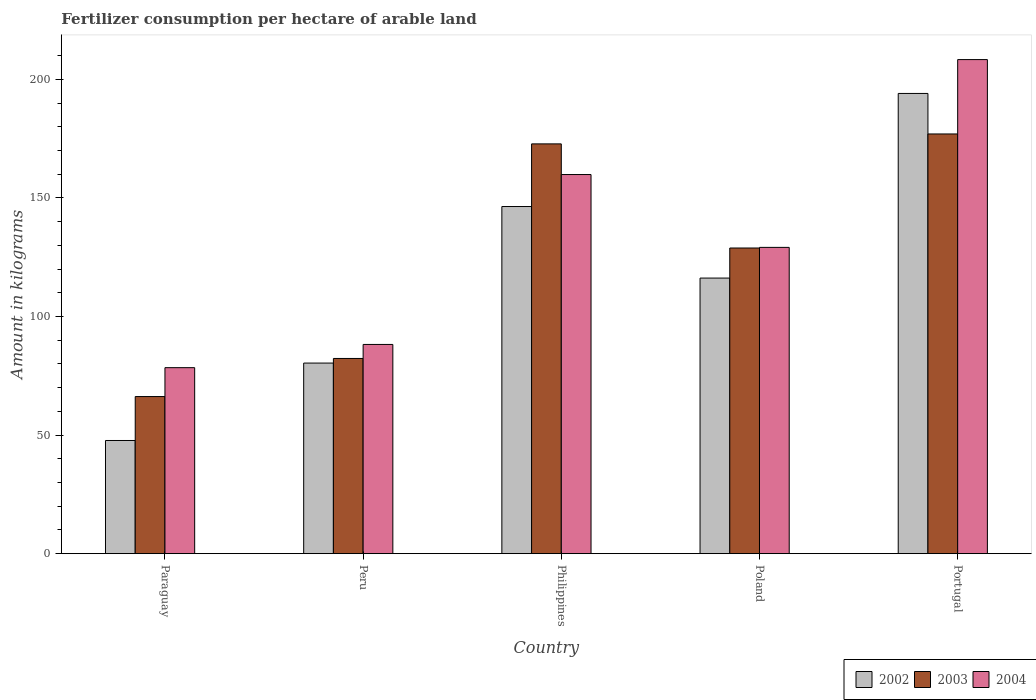How many groups of bars are there?
Give a very brief answer. 5. Are the number of bars on each tick of the X-axis equal?
Your answer should be compact. Yes. How many bars are there on the 1st tick from the left?
Keep it short and to the point. 3. In how many cases, is the number of bars for a given country not equal to the number of legend labels?
Offer a terse response. 0. What is the amount of fertilizer consumption in 2002 in Philippines?
Your answer should be compact. 146.36. Across all countries, what is the maximum amount of fertilizer consumption in 2002?
Your answer should be very brief. 194.04. Across all countries, what is the minimum amount of fertilizer consumption in 2004?
Ensure brevity in your answer.  78.42. In which country was the amount of fertilizer consumption in 2004 minimum?
Make the answer very short. Paraguay. What is the total amount of fertilizer consumption in 2002 in the graph?
Your response must be concise. 584.66. What is the difference between the amount of fertilizer consumption in 2002 in Paraguay and that in Portugal?
Keep it short and to the point. -146.32. What is the difference between the amount of fertilizer consumption in 2004 in Philippines and the amount of fertilizer consumption in 2002 in Paraguay?
Your answer should be compact. 112.13. What is the average amount of fertilizer consumption in 2002 per country?
Offer a very short reply. 116.93. What is the difference between the amount of fertilizer consumption of/in 2004 and amount of fertilizer consumption of/in 2003 in Paraguay?
Give a very brief answer. 12.18. In how many countries, is the amount of fertilizer consumption in 2003 greater than 110 kg?
Give a very brief answer. 3. What is the ratio of the amount of fertilizer consumption in 2004 in Poland to that in Portugal?
Make the answer very short. 0.62. Is the amount of fertilizer consumption in 2004 in Peru less than that in Philippines?
Ensure brevity in your answer.  Yes. What is the difference between the highest and the second highest amount of fertilizer consumption in 2002?
Offer a terse response. 77.84. What is the difference between the highest and the lowest amount of fertilizer consumption in 2002?
Provide a short and direct response. 146.32. In how many countries, is the amount of fertilizer consumption in 2003 greater than the average amount of fertilizer consumption in 2003 taken over all countries?
Ensure brevity in your answer.  3. How many bars are there?
Make the answer very short. 15. What is the difference between two consecutive major ticks on the Y-axis?
Provide a succinct answer. 50. Are the values on the major ticks of Y-axis written in scientific E-notation?
Keep it short and to the point. No. Does the graph contain any zero values?
Your response must be concise. No. Does the graph contain grids?
Your answer should be compact. No. How many legend labels are there?
Your answer should be very brief. 3. How are the legend labels stacked?
Ensure brevity in your answer.  Horizontal. What is the title of the graph?
Offer a very short reply. Fertilizer consumption per hectare of arable land. What is the label or title of the X-axis?
Your answer should be compact. Country. What is the label or title of the Y-axis?
Offer a terse response. Amount in kilograms. What is the Amount in kilograms in 2002 in Paraguay?
Offer a terse response. 47.72. What is the Amount in kilograms in 2003 in Paraguay?
Provide a short and direct response. 66.24. What is the Amount in kilograms of 2004 in Paraguay?
Your answer should be compact. 78.42. What is the Amount in kilograms of 2002 in Peru?
Provide a succinct answer. 80.35. What is the Amount in kilograms of 2003 in Peru?
Provide a short and direct response. 82.3. What is the Amount in kilograms in 2004 in Peru?
Offer a terse response. 88.21. What is the Amount in kilograms in 2002 in Philippines?
Offer a terse response. 146.36. What is the Amount in kilograms of 2003 in Philippines?
Ensure brevity in your answer.  172.77. What is the Amount in kilograms of 2004 in Philippines?
Offer a terse response. 159.85. What is the Amount in kilograms of 2002 in Poland?
Your answer should be very brief. 116.2. What is the Amount in kilograms in 2003 in Poland?
Your answer should be compact. 128.87. What is the Amount in kilograms of 2004 in Poland?
Provide a short and direct response. 129.14. What is the Amount in kilograms of 2002 in Portugal?
Your answer should be compact. 194.04. What is the Amount in kilograms of 2003 in Portugal?
Keep it short and to the point. 176.96. What is the Amount in kilograms of 2004 in Portugal?
Provide a short and direct response. 208.31. Across all countries, what is the maximum Amount in kilograms of 2002?
Give a very brief answer. 194.04. Across all countries, what is the maximum Amount in kilograms in 2003?
Ensure brevity in your answer.  176.96. Across all countries, what is the maximum Amount in kilograms of 2004?
Give a very brief answer. 208.31. Across all countries, what is the minimum Amount in kilograms of 2002?
Offer a very short reply. 47.72. Across all countries, what is the minimum Amount in kilograms in 2003?
Make the answer very short. 66.24. Across all countries, what is the minimum Amount in kilograms of 2004?
Give a very brief answer. 78.42. What is the total Amount in kilograms of 2002 in the graph?
Make the answer very short. 584.66. What is the total Amount in kilograms in 2003 in the graph?
Provide a succinct answer. 627.13. What is the total Amount in kilograms of 2004 in the graph?
Provide a short and direct response. 663.93. What is the difference between the Amount in kilograms in 2002 in Paraguay and that in Peru?
Keep it short and to the point. -32.64. What is the difference between the Amount in kilograms in 2003 in Paraguay and that in Peru?
Make the answer very short. -16.06. What is the difference between the Amount in kilograms in 2004 in Paraguay and that in Peru?
Your response must be concise. -9.79. What is the difference between the Amount in kilograms in 2002 in Paraguay and that in Philippines?
Provide a short and direct response. -98.65. What is the difference between the Amount in kilograms in 2003 in Paraguay and that in Philippines?
Offer a very short reply. -106.53. What is the difference between the Amount in kilograms in 2004 in Paraguay and that in Philippines?
Your answer should be compact. -81.42. What is the difference between the Amount in kilograms of 2002 in Paraguay and that in Poland?
Offer a terse response. -68.48. What is the difference between the Amount in kilograms of 2003 in Paraguay and that in Poland?
Ensure brevity in your answer.  -62.63. What is the difference between the Amount in kilograms of 2004 in Paraguay and that in Poland?
Make the answer very short. -50.71. What is the difference between the Amount in kilograms in 2002 in Paraguay and that in Portugal?
Make the answer very short. -146.32. What is the difference between the Amount in kilograms of 2003 in Paraguay and that in Portugal?
Your answer should be compact. -110.72. What is the difference between the Amount in kilograms of 2004 in Paraguay and that in Portugal?
Provide a short and direct response. -129.89. What is the difference between the Amount in kilograms in 2002 in Peru and that in Philippines?
Offer a terse response. -66.01. What is the difference between the Amount in kilograms in 2003 in Peru and that in Philippines?
Your response must be concise. -90.47. What is the difference between the Amount in kilograms of 2004 in Peru and that in Philippines?
Your response must be concise. -71.63. What is the difference between the Amount in kilograms in 2002 in Peru and that in Poland?
Your response must be concise. -35.84. What is the difference between the Amount in kilograms in 2003 in Peru and that in Poland?
Your answer should be compact. -46.57. What is the difference between the Amount in kilograms in 2004 in Peru and that in Poland?
Give a very brief answer. -40.92. What is the difference between the Amount in kilograms in 2002 in Peru and that in Portugal?
Provide a succinct answer. -113.68. What is the difference between the Amount in kilograms in 2003 in Peru and that in Portugal?
Make the answer very short. -94.66. What is the difference between the Amount in kilograms in 2004 in Peru and that in Portugal?
Offer a terse response. -120.1. What is the difference between the Amount in kilograms of 2002 in Philippines and that in Poland?
Ensure brevity in your answer.  30.17. What is the difference between the Amount in kilograms in 2003 in Philippines and that in Poland?
Give a very brief answer. 43.9. What is the difference between the Amount in kilograms of 2004 in Philippines and that in Poland?
Make the answer very short. 30.71. What is the difference between the Amount in kilograms in 2002 in Philippines and that in Portugal?
Keep it short and to the point. -47.68. What is the difference between the Amount in kilograms of 2003 in Philippines and that in Portugal?
Offer a very short reply. -4.19. What is the difference between the Amount in kilograms in 2004 in Philippines and that in Portugal?
Ensure brevity in your answer.  -48.47. What is the difference between the Amount in kilograms in 2002 in Poland and that in Portugal?
Your answer should be compact. -77.84. What is the difference between the Amount in kilograms of 2003 in Poland and that in Portugal?
Keep it short and to the point. -48.09. What is the difference between the Amount in kilograms in 2004 in Poland and that in Portugal?
Make the answer very short. -79.18. What is the difference between the Amount in kilograms of 2002 in Paraguay and the Amount in kilograms of 2003 in Peru?
Offer a terse response. -34.58. What is the difference between the Amount in kilograms in 2002 in Paraguay and the Amount in kilograms in 2004 in Peru?
Keep it short and to the point. -40.5. What is the difference between the Amount in kilograms in 2003 in Paraguay and the Amount in kilograms in 2004 in Peru?
Provide a succinct answer. -21.97. What is the difference between the Amount in kilograms of 2002 in Paraguay and the Amount in kilograms of 2003 in Philippines?
Ensure brevity in your answer.  -125.05. What is the difference between the Amount in kilograms of 2002 in Paraguay and the Amount in kilograms of 2004 in Philippines?
Provide a short and direct response. -112.13. What is the difference between the Amount in kilograms of 2003 in Paraguay and the Amount in kilograms of 2004 in Philippines?
Ensure brevity in your answer.  -93.61. What is the difference between the Amount in kilograms in 2002 in Paraguay and the Amount in kilograms in 2003 in Poland?
Your answer should be very brief. -81.16. What is the difference between the Amount in kilograms in 2002 in Paraguay and the Amount in kilograms in 2004 in Poland?
Offer a very short reply. -81.42. What is the difference between the Amount in kilograms in 2003 in Paraguay and the Amount in kilograms in 2004 in Poland?
Your answer should be compact. -62.9. What is the difference between the Amount in kilograms in 2002 in Paraguay and the Amount in kilograms in 2003 in Portugal?
Provide a succinct answer. -129.24. What is the difference between the Amount in kilograms of 2002 in Paraguay and the Amount in kilograms of 2004 in Portugal?
Offer a terse response. -160.6. What is the difference between the Amount in kilograms in 2003 in Paraguay and the Amount in kilograms in 2004 in Portugal?
Provide a succinct answer. -142.08. What is the difference between the Amount in kilograms of 2002 in Peru and the Amount in kilograms of 2003 in Philippines?
Give a very brief answer. -92.41. What is the difference between the Amount in kilograms of 2002 in Peru and the Amount in kilograms of 2004 in Philippines?
Your answer should be compact. -79.49. What is the difference between the Amount in kilograms in 2003 in Peru and the Amount in kilograms in 2004 in Philippines?
Offer a terse response. -77.55. What is the difference between the Amount in kilograms of 2002 in Peru and the Amount in kilograms of 2003 in Poland?
Your response must be concise. -48.52. What is the difference between the Amount in kilograms of 2002 in Peru and the Amount in kilograms of 2004 in Poland?
Provide a short and direct response. -48.78. What is the difference between the Amount in kilograms of 2003 in Peru and the Amount in kilograms of 2004 in Poland?
Your answer should be compact. -46.84. What is the difference between the Amount in kilograms of 2002 in Peru and the Amount in kilograms of 2003 in Portugal?
Your answer should be compact. -96.6. What is the difference between the Amount in kilograms in 2002 in Peru and the Amount in kilograms in 2004 in Portugal?
Your answer should be compact. -127.96. What is the difference between the Amount in kilograms of 2003 in Peru and the Amount in kilograms of 2004 in Portugal?
Give a very brief answer. -126.02. What is the difference between the Amount in kilograms of 2002 in Philippines and the Amount in kilograms of 2003 in Poland?
Your answer should be very brief. 17.49. What is the difference between the Amount in kilograms of 2002 in Philippines and the Amount in kilograms of 2004 in Poland?
Offer a very short reply. 17.23. What is the difference between the Amount in kilograms of 2003 in Philippines and the Amount in kilograms of 2004 in Poland?
Offer a terse response. 43.63. What is the difference between the Amount in kilograms in 2002 in Philippines and the Amount in kilograms in 2003 in Portugal?
Ensure brevity in your answer.  -30.6. What is the difference between the Amount in kilograms of 2002 in Philippines and the Amount in kilograms of 2004 in Portugal?
Offer a very short reply. -61.95. What is the difference between the Amount in kilograms in 2003 in Philippines and the Amount in kilograms in 2004 in Portugal?
Your response must be concise. -35.55. What is the difference between the Amount in kilograms in 2002 in Poland and the Amount in kilograms in 2003 in Portugal?
Keep it short and to the point. -60.76. What is the difference between the Amount in kilograms in 2002 in Poland and the Amount in kilograms in 2004 in Portugal?
Make the answer very short. -92.12. What is the difference between the Amount in kilograms of 2003 in Poland and the Amount in kilograms of 2004 in Portugal?
Your response must be concise. -79.44. What is the average Amount in kilograms in 2002 per country?
Give a very brief answer. 116.93. What is the average Amount in kilograms in 2003 per country?
Your response must be concise. 125.43. What is the average Amount in kilograms of 2004 per country?
Your response must be concise. 132.79. What is the difference between the Amount in kilograms in 2002 and Amount in kilograms in 2003 in Paraguay?
Provide a short and direct response. -18.52. What is the difference between the Amount in kilograms in 2002 and Amount in kilograms in 2004 in Paraguay?
Offer a very short reply. -30.71. What is the difference between the Amount in kilograms in 2003 and Amount in kilograms in 2004 in Paraguay?
Provide a succinct answer. -12.18. What is the difference between the Amount in kilograms of 2002 and Amount in kilograms of 2003 in Peru?
Provide a short and direct response. -1.94. What is the difference between the Amount in kilograms of 2002 and Amount in kilograms of 2004 in Peru?
Provide a short and direct response. -7.86. What is the difference between the Amount in kilograms in 2003 and Amount in kilograms in 2004 in Peru?
Offer a very short reply. -5.91. What is the difference between the Amount in kilograms in 2002 and Amount in kilograms in 2003 in Philippines?
Offer a terse response. -26.41. What is the difference between the Amount in kilograms in 2002 and Amount in kilograms in 2004 in Philippines?
Provide a succinct answer. -13.48. What is the difference between the Amount in kilograms of 2003 and Amount in kilograms of 2004 in Philippines?
Your answer should be very brief. 12.92. What is the difference between the Amount in kilograms of 2002 and Amount in kilograms of 2003 in Poland?
Give a very brief answer. -12.68. What is the difference between the Amount in kilograms of 2002 and Amount in kilograms of 2004 in Poland?
Give a very brief answer. -12.94. What is the difference between the Amount in kilograms of 2003 and Amount in kilograms of 2004 in Poland?
Your response must be concise. -0.26. What is the difference between the Amount in kilograms in 2002 and Amount in kilograms in 2003 in Portugal?
Provide a succinct answer. 17.08. What is the difference between the Amount in kilograms of 2002 and Amount in kilograms of 2004 in Portugal?
Your answer should be compact. -14.28. What is the difference between the Amount in kilograms of 2003 and Amount in kilograms of 2004 in Portugal?
Keep it short and to the point. -31.36. What is the ratio of the Amount in kilograms in 2002 in Paraguay to that in Peru?
Provide a short and direct response. 0.59. What is the ratio of the Amount in kilograms in 2003 in Paraguay to that in Peru?
Ensure brevity in your answer.  0.8. What is the ratio of the Amount in kilograms of 2004 in Paraguay to that in Peru?
Keep it short and to the point. 0.89. What is the ratio of the Amount in kilograms in 2002 in Paraguay to that in Philippines?
Keep it short and to the point. 0.33. What is the ratio of the Amount in kilograms in 2003 in Paraguay to that in Philippines?
Provide a short and direct response. 0.38. What is the ratio of the Amount in kilograms of 2004 in Paraguay to that in Philippines?
Make the answer very short. 0.49. What is the ratio of the Amount in kilograms of 2002 in Paraguay to that in Poland?
Your response must be concise. 0.41. What is the ratio of the Amount in kilograms in 2003 in Paraguay to that in Poland?
Offer a very short reply. 0.51. What is the ratio of the Amount in kilograms in 2004 in Paraguay to that in Poland?
Your response must be concise. 0.61. What is the ratio of the Amount in kilograms of 2002 in Paraguay to that in Portugal?
Give a very brief answer. 0.25. What is the ratio of the Amount in kilograms of 2003 in Paraguay to that in Portugal?
Provide a short and direct response. 0.37. What is the ratio of the Amount in kilograms of 2004 in Paraguay to that in Portugal?
Keep it short and to the point. 0.38. What is the ratio of the Amount in kilograms of 2002 in Peru to that in Philippines?
Your answer should be very brief. 0.55. What is the ratio of the Amount in kilograms in 2003 in Peru to that in Philippines?
Offer a very short reply. 0.48. What is the ratio of the Amount in kilograms in 2004 in Peru to that in Philippines?
Provide a succinct answer. 0.55. What is the ratio of the Amount in kilograms of 2002 in Peru to that in Poland?
Ensure brevity in your answer.  0.69. What is the ratio of the Amount in kilograms in 2003 in Peru to that in Poland?
Give a very brief answer. 0.64. What is the ratio of the Amount in kilograms in 2004 in Peru to that in Poland?
Keep it short and to the point. 0.68. What is the ratio of the Amount in kilograms in 2002 in Peru to that in Portugal?
Ensure brevity in your answer.  0.41. What is the ratio of the Amount in kilograms in 2003 in Peru to that in Portugal?
Offer a very short reply. 0.47. What is the ratio of the Amount in kilograms of 2004 in Peru to that in Portugal?
Ensure brevity in your answer.  0.42. What is the ratio of the Amount in kilograms in 2002 in Philippines to that in Poland?
Offer a very short reply. 1.26. What is the ratio of the Amount in kilograms in 2003 in Philippines to that in Poland?
Provide a short and direct response. 1.34. What is the ratio of the Amount in kilograms of 2004 in Philippines to that in Poland?
Your answer should be very brief. 1.24. What is the ratio of the Amount in kilograms of 2002 in Philippines to that in Portugal?
Keep it short and to the point. 0.75. What is the ratio of the Amount in kilograms of 2003 in Philippines to that in Portugal?
Offer a terse response. 0.98. What is the ratio of the Amount in kilograms of 2004 in Philippines to that in Portugal?
Offer a terse response. 0.77. What is the ratio of the Amount in kilograms of 2002 in Poland to that in Portugal?
Your response must be concise. 0.6. What is the ratio of the Amount in kilograms in 2003 in Poland to that in Portugal?
Make the answer very short. 0.73. What is the ratio of the Amount in kilograms in 2004 in Poland to that in Portugal?
Offer a terse response. 0.62. What is the difference between the highest and the second highest Amount in kilograms in 2002?
Make the answer very short. 47.68. What is the difference between the highest and the second highest Amount in kilograms of 2003?
Your answer should be compact. 4.19. What is the difference between the highest and the second highest Amount in kilograms of 2004?
Provide a short and direct response. 48.47. What is the difference between the highest and the lowest Amount in kilograms in 2002?
Your response must be concise. 146.32. What is the difference between the highest and the lowest Amount in kilograms in 2003?
Offer a terse response. 110.72. What is the difference between the highest and the lowest Amount in kilograms in 2004?
Your answer should be very brief. 129.89. 